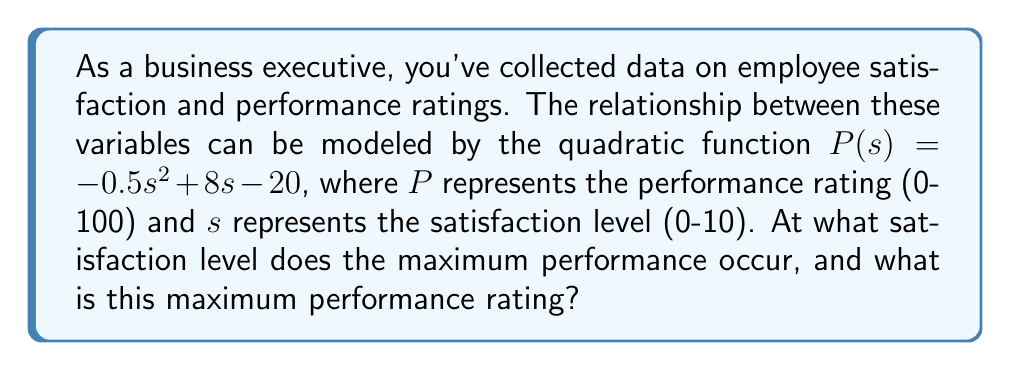Provide a solution to this math problem. To find the maximum point of a quadratic function, we follow these steps:

1) The general form of a quadratic function is $f(x) = ax^2 + bx + c$
   In this case, $a = -0.5$, $b = 8$, and $c = -20$

2) The x-coordinate of the vertex (which represents the satisfaction level at maximum performance) is given by the formula: $x = -\frac{b}{2a}$

3) Substituting our values:
   $s = -\frac{8}{2(-0.5)} = -\frac{8}{-1} = 8$

4) To find the maximum performance rating, we substitute this s-value into our original function:

   $P(8) = -0.5(8)^2 + 8(8) - 20$
         $= -0.5(64) + 64 - 20$
         $= -32 + 64 - 20$
         $= 12$

5) Therefore, the maximum performance occurs at a satisfaction level of 8, and the maximum performance rating is 12.
Answer: Satisfaction level: 8; Maximum performance rating: 12 